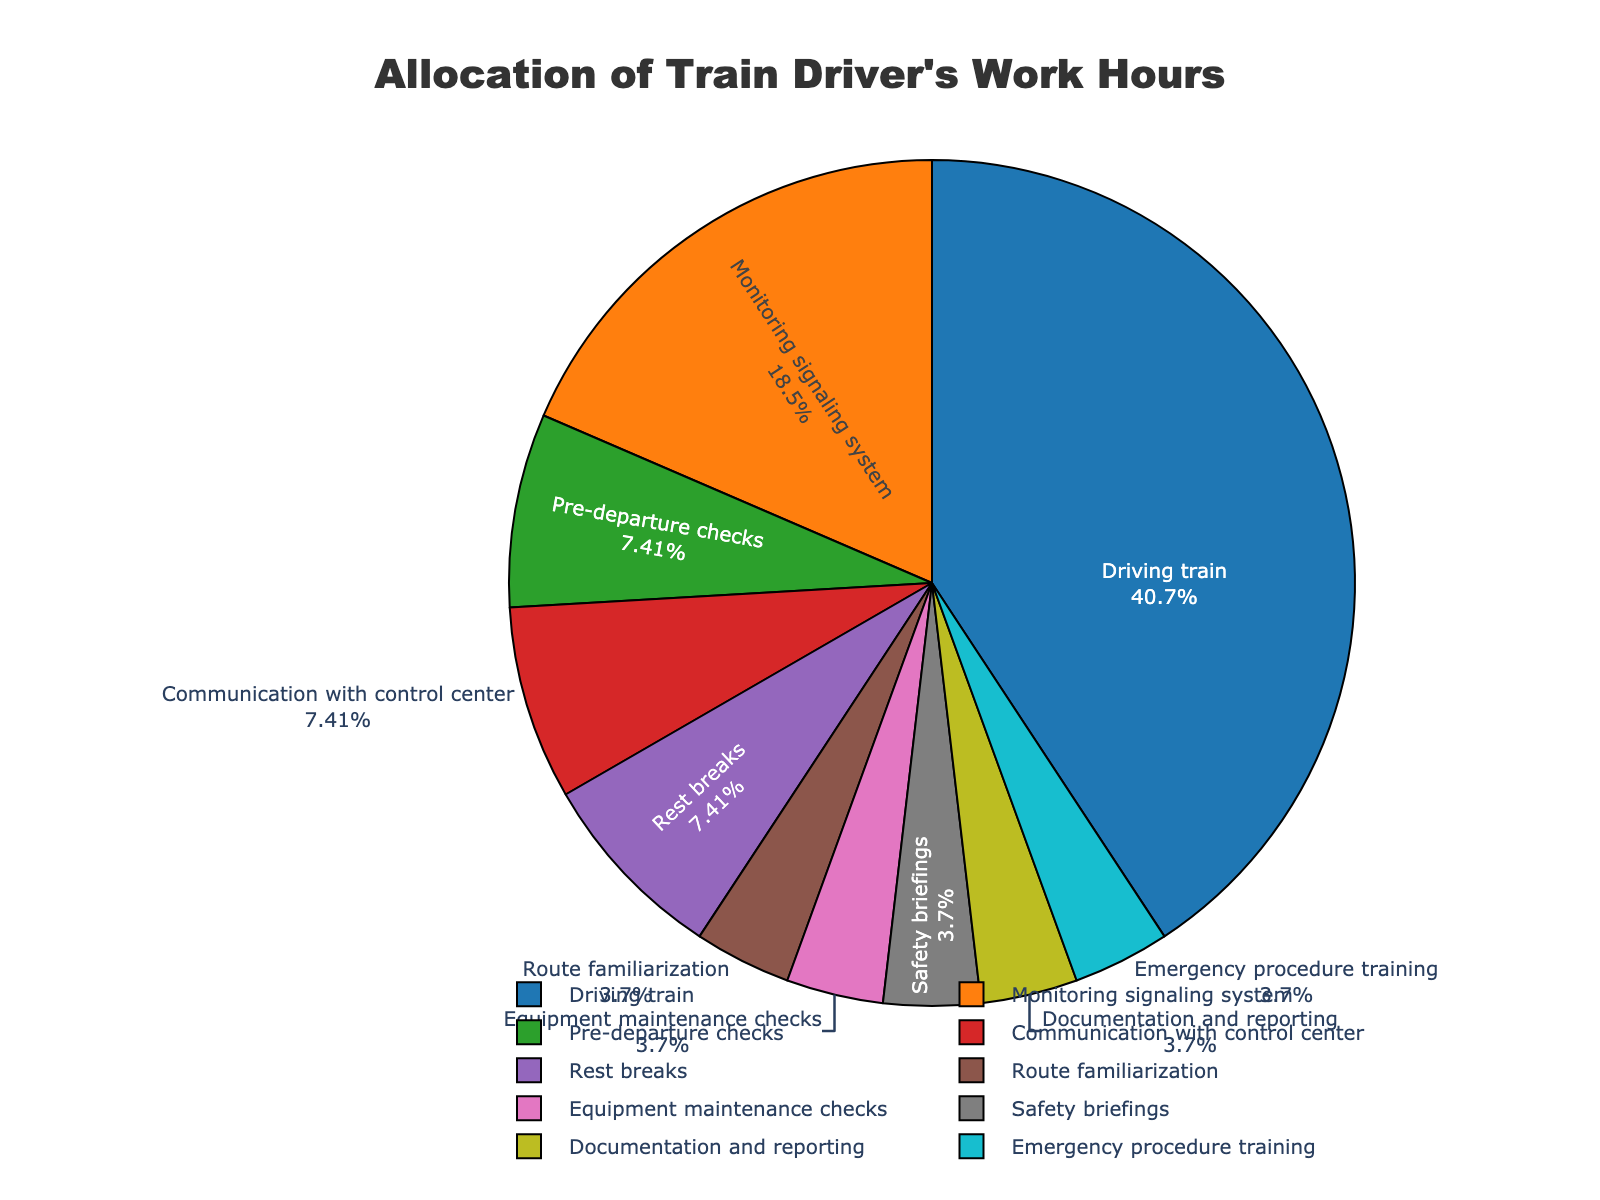which task takes up the largest portion of work hours? By examining the pie chart, the largest portion of the chart is labeled "Driving train".
Answer: Driving train how many hours are allocated to tasks related to safety (like safety briefings and emergency procedure training)? According to the chart, Safety briefings and Emergency procedure training each take 0.5 hours, so the total is 0.5 + 0.5.
Answer: 1 hour which task takes up more hours, route familiarization or documentation and reporting? By comparing the slices labeled "Route familiarization" and "Documentation and reporting", we can see that both take up 0.5 hours each.
Answer: Both are equal what percentage of total work hours is spent on rest breaks? The pie chart provides percentages. The slice labeled "Rest breaks" shows 10% of total hours.
Answer: 10% how many tasks have 1 hour or more allocated to them? By examining the pie chart, the tasks with 1 hour or more are: Driving train, Monitoring signaling system, Pre-departure checks, Communication with control center, and Rest breaks, totaling 5 tasks.
Answer: 5 tasks what is the combined percentage of work hours spent on tasks other than driving the train? The pie chart shows "Driving train" as 55%. The combined percentage of all other tasks is 100% - 55%.
Answer: 45% which takes more hours, equipment maintenance checks or communication with control center? By comparing the slices labeled "Equipment maintenance checks" and "Communication with control center", we see that Communication with control center takes 1 hour while Equipment maintenance checks take 0.5 hours.
Answer: Communication with control center what portion of the pie chart is contributed by tasks that take exactly 0.5 hours? The tasks that each take 0.5 hours are Route familiarization, Equipment maintenance checks, Safety briefings, Documentation and reporting, and Emergency procedure training. Each portion is 5%, so 5 tasks total 5% * 5.
Answer: 25% which tasks together equal the hours spent on monitoring the signaling system? Monitoring signaling system takes 2.5 hours. The tasks matching this by hours would be adding together 5 tasks that take 0.5 hours each: Route familiarization, Equipment maintenance checks, Safety briefings, Documentation and reporting, and Emergency procedure training. So 5 * 0.5 = 2.5 hours.
Answer: 5 tasks 